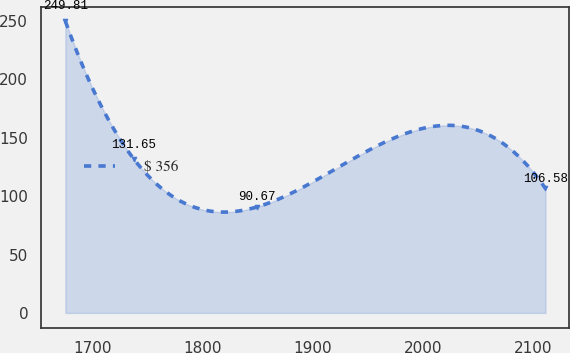Convert chart to OTSL. <chart><loc_0><loc_0><loc_500><loc_500><line_chart><ecel><fcel>$ 356<nl><fcel>1675.58<fcel>249.81<nl><fcel>1737.83<fcel>131.65<nl><fcel>1849.31<fcel>90.67<nl><fcel>2111.48<fcel>106.58<nl></chart> 